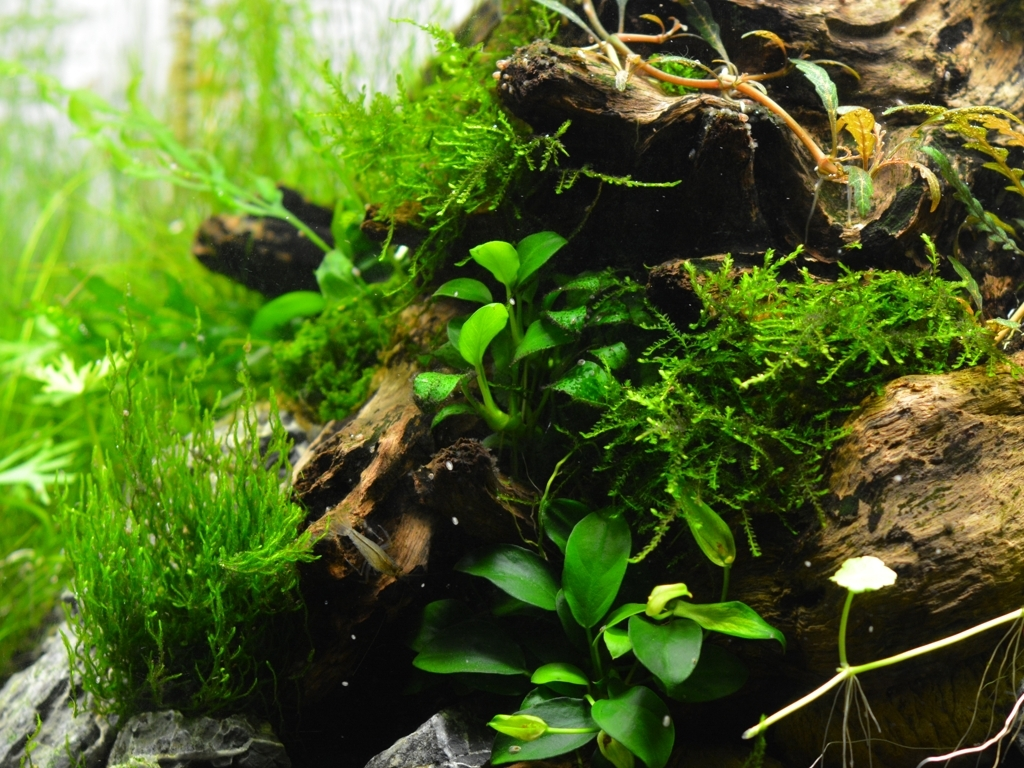What species of plants can be seen in this image? The image displays a variety of aquatic plants commonly used in aquariums. While I cannot positively identify every plant species without genetic analysis, we can see what looks like Java fern, known for its broad leaves and hardy nature, and there appears to be moss, possibly Java moss, which is often used to create lush green carpets in aquarium settings. 